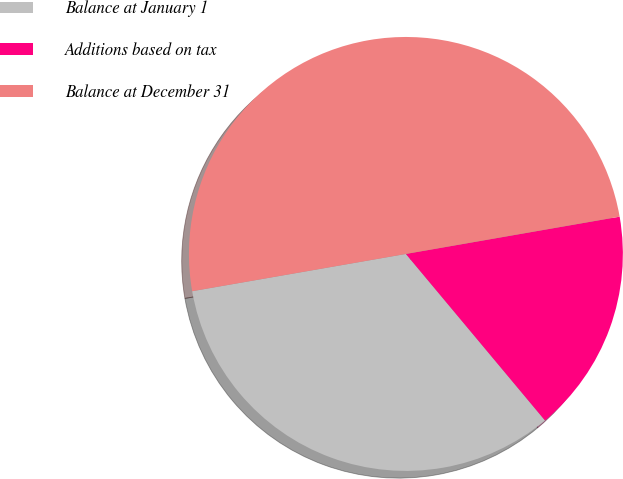Convert chart to OTSL. <chart><loc_0><loc_0><loc_500><loc_500><pie_chart><fcel>Balance at January 1<fcel>Additions based on tax<fcel>Balance at December 31<nl><fcel>33.33%<fcel>16.67%<fcel>50.0%<nl></chart> 